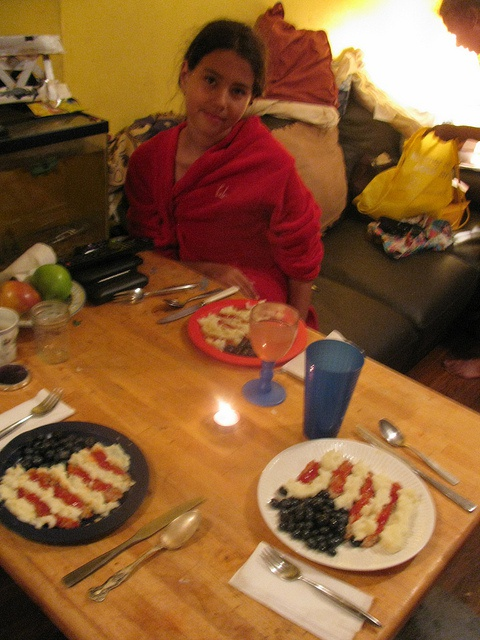Describe the objects in this image and their specific colors. I can see dining table in olive, red, black, and tan tones, couch in olive, black, maroon, and brown tones, people in olive, maroon, black, and brown tones, handbag in olive, orange, and black tones, and cup in olive, black, gray, and darkblue tones in this image. 